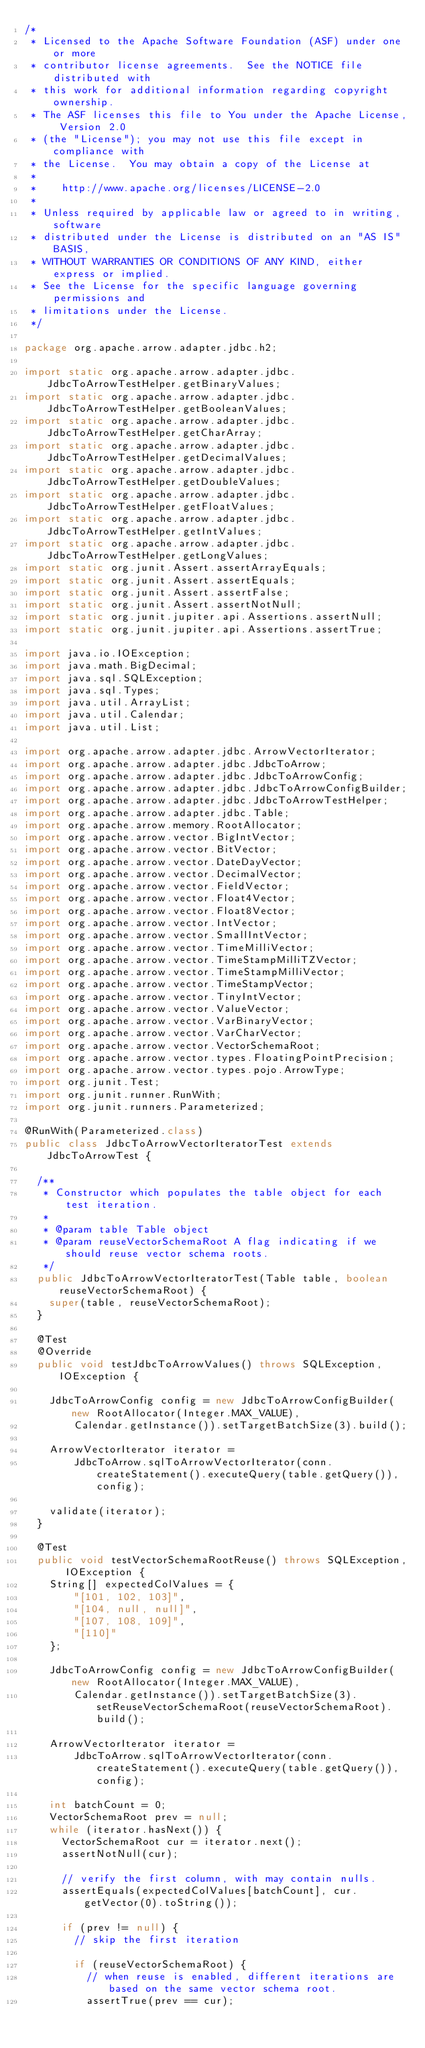<code> <loc_0><loc_0><loc_500><loc_500><_Java_>/*
 * Licensed to the Apache Software Foundation (ASF) under one or more
 * contributor license agreements.  See the NOTICE file distributed with
 * this work for additional information regarding copyright ownership.
 * The ASF licenses this file to You under the Apache License, Version 2.0
 * (the "License"); you may not use this file except in compliance with
 * the License.  You may obtain a copy of the License at
 *
 *    http://www.apache.org/licenses/LICENSE-2.0
 *
 * Unless required by applicable law or agreed to in writing, software
 * distributed under the License is distributed on an "AS IS" BASIS,
 * WITHOUT WARRANTIES OR CONDITIONS OF ANY KIND, either express or implied.
 * See the License for the specific language governing permissions and
 * limitations under the License.
 */

package org.apache.arrow.adapter.jdbc.h2;

import static org.apache.arrow.adapter.jdbc.JdbcToArrowTestHelper.getBinaryValues;
import static org.apache.arrow.adapter.jdbc.JdbcToArrowTestHelper.getBooleanValues;
import static org.apache.arrow.adapter.jdbc.JdbcToArrowTestHelper.getCharArray;
import static org.apache.arrow.adapter.jdbc.JdbcToArrowTestHelper.getDecimalValues;
import static org.apache.arrow.adapter.jdbc.JdbcToArrowTestHelper.getDoubleValues;
import static org.apache.arrow.adapter.jdbc.JdbcToArrowTestHelper.getFloatValues;
import static org.apache.arrow.adapter.jdbc.JdbcToArrowTestHelper.getIntValues;
import static org.apache.arrow.adapter.jdbc.JdbcToArrowTestHelper.getLongValues;
import static org.junit.Assert.assertArrayEquals;
import static org.junit.Assert.assertEquals;
import static org.junit.Assert.assertFalse;
import static org.junit.Assert.assertNotNull;
import static org.junit.jupiter.api.Assertions.assertNull;
import static org.junit.jupiter.api.Assertions.assertTrue;

import java.io.IOException;
import java.math.BigDecimal;
import java.sql.SQLException;
import java.sql.Types;
import java.util.ArrayList;
import java.util.Calendar;
import java.util.List;

import org.apache.arrow.adapter.jdbc.ArrowVectorIterator;
import org.apache.arrow.adapter.jdbc.JdbcToArrow;
import org.apache.arrow.adapter.jdbc.JdbcToArrowConfig;
import org.apache.arrow.adapter.jdbc.JdbcToArrowConfigBuilder;
import org.apache.arrow.adapter.jdbc.JdbcToArrowTestHelper;
import org.apache.arrow.adapter.jdbc.Table;
import org.apache.arrow.memory.RootAllocator;
import org.apache.arrow.vector.BigIntVector;
import org.apache.arrow.vector.BitVector;
import org.apache.arrow.vector.DateDayVector;
import org.apache.arrow.vector.DecimalVector;
import org.apache.arrow.vector.FieldVector;
import org.apache.arrow.vector.Float4Vector;
import org.apache.arrow.vector.Float8Vector;
import org.apache.arrow.vector.IntVector;
import org.apache.arrow.vector.SmallIntVector;
import org.apache.arrow.vector.TimeMilliVector;
import org.apache.arrow.vector.TimeStampMilliTZVector;
import org.apache.arrow.vector.TimeStampMilliVector;
import org.apache.arrow.vector.TimeStampVector;
import org.apache.arrow.vector.TinyIntVector;
import org.apache.arrow.vector.ValueVector;
import org.apache.arrow.vector.VarBinaryVector;
import org.apache.arrow.vector.VarCharVector;
import org.apache.arrow.vector.VectorSchemaRoot;
import org.apache.arrow.vector.types.FloatingPointPrecision;
import org.apache.arrow.vector.types.pojo.ArrowType;
import org.junit.Test;
import org.junit.runner.RunWith;
import org.junit.runners.Parameterized;

@RunWith(Parameterized.class)
public class JdbcToArrowVectorIteratorTest extends JdbcToArrowTest {

  /**
   * Constructor which populates the table object for each test iteration.
   *
   * @param table Table object
   * @param reuseVectorSchemaRoot A flag indicating if we should reuse vector schema roots.
   */
  public JdbcToArrowVectorIteratorTest(Table table, boolean reuseVectorSchemaRoot) {
    super(table, reuseVectorSchemaRoot);
  }

  @Test
  @Override
  public void testJdbcToArrowValues() throws SQLException, IOException {

    JdbcToArrowConfig config = new JdbcToArrowConfigBuilder(new RootAllocator(Integer.MAX_VALUE),
        Calendar.getInstance()).setTargetBatchSize(3).build();

    ArrowVectorIterator iterator =
        JdbcToArrow.sqlToArrowVectorIterator(conn.createStatement().executeQuery(table.getQuery()), config);

    validate(iterator);
  }

  @Test
  public void testVectorSchemaRootReuse() throws SQLException, IOException {
    String[] expectedColValues = {
        "[101, 102, 103]",
        "[104, null, null]",
        "[107, 108, 109]",
        "[110]"
    };

    JdbcToArrowConfig config = new JdbcToArrowConfigBuilder(new RootAllocator(Integer.MAX_VALUE),
        Calendar.getInstance()).setTargetBatchSize(3).setReuseVectorSchemaRoot(reuseVectorSchemaRoot).build();

    ArrowVectorIterator iterator =
        JdbcToArrow.sqlToArrowVectorIterator(conn.createStatement().executeQuery(table.getQuery()), config);

    int batchCount = 0;
    VectorSchemaRoot prev = null;
    while (iterator.hasNext()) {
      VectorSchemaRoot cur = iterator.next();
      assertNotNull(cur);

      // verify the first column, with may contain nulls.
      assertEquals(expectedColValues[batchCount], cur.getVector(0).toString());

      if (prev != null) {
        // skip the first iteration

        if (reuseVectorSchemaRoot) {
          // when reuse is enabled, different iterations are based on the same vector schema root.
          assertTrue(prev == cur);</code> 